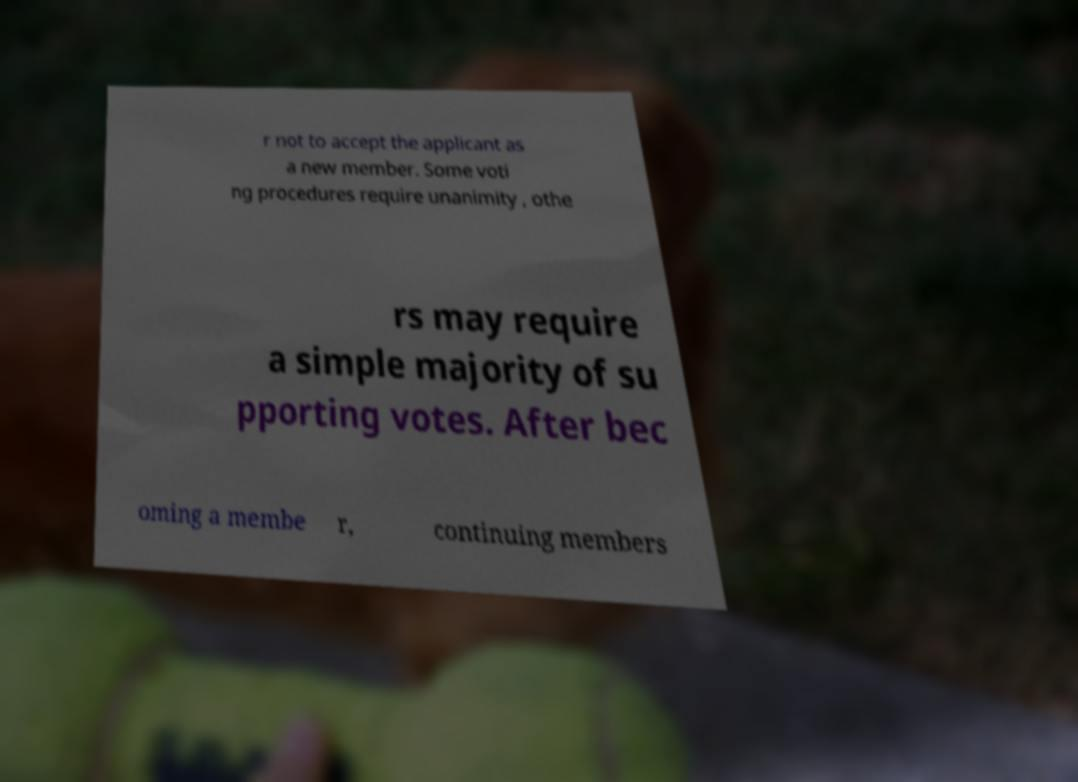There's text embedded in this image that I need extracted. Can you transcribe it verbatim? r not to accept the applicant as a new member. Some voti ng procedures require unanimity , othe rs may require a simple majority of su pporting votes. After bec oming a membe r, continuing members 